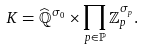<formula> <loc_0><loc_0><loc_500><loc_500>K = \widehat { \mathbb { Q } } ^ { \sigma _ { 0 } } \times \prod _ { p \in \mathbb { P } } \mathbb { Z } _ { p } ^ { \sigma _ { p } } .</formula> 